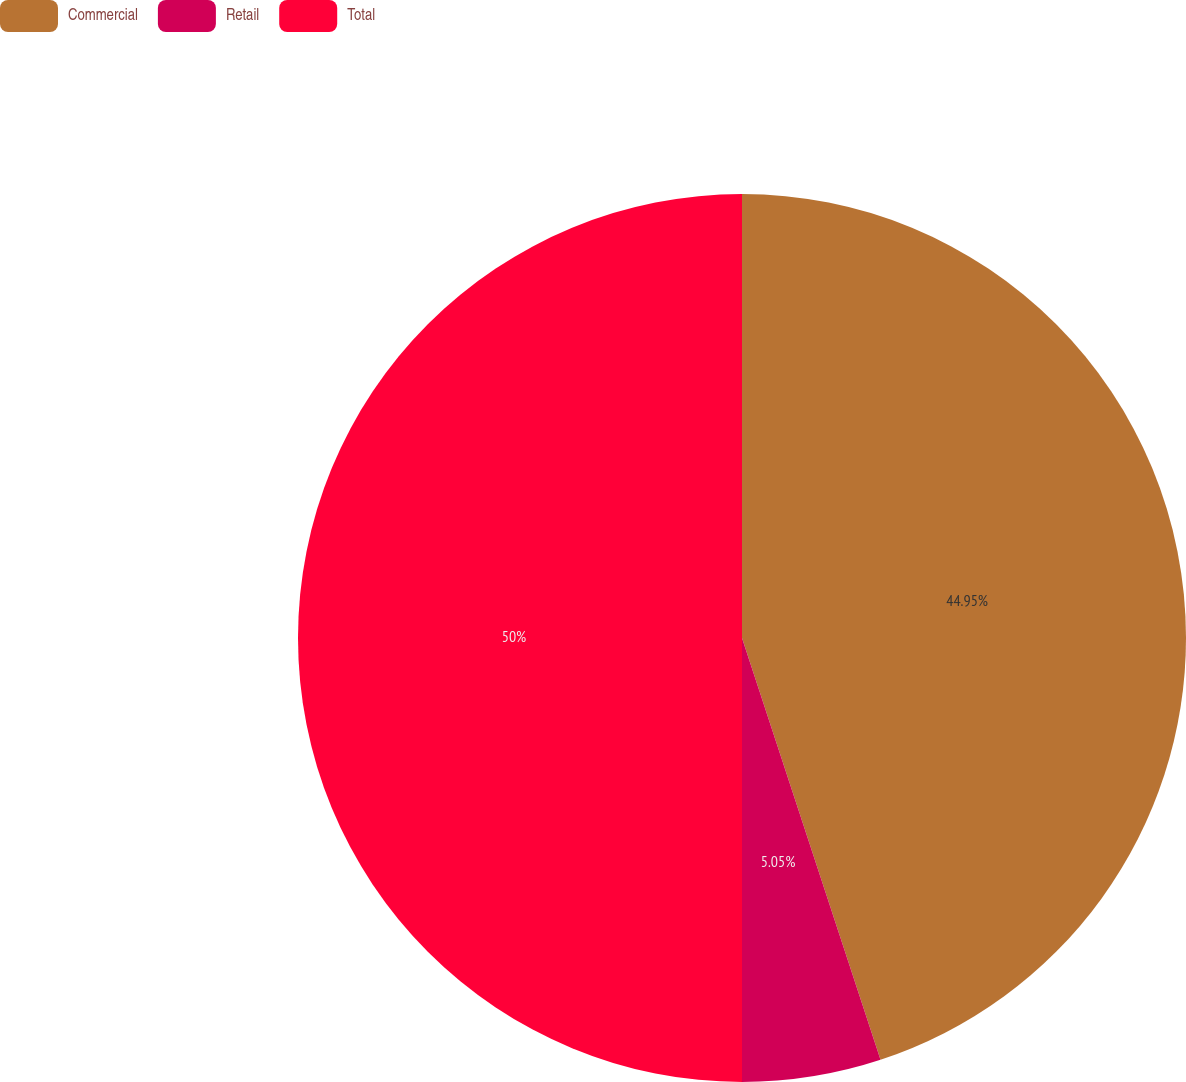<chart> <loc_0><loc_0><loc_500><loc_500><pie_chart><fcel>Commercial<fcel>Retail<fcel>Total<nl><fcel>44.95%<fcel>5.05%<fcel>50.0%<nl></chart> 